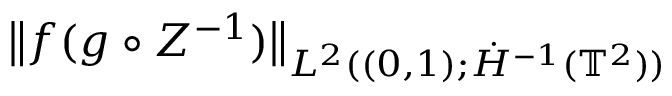Convert formula to latex. <formula><loc_0><loc_0><loc_500><loc_500>\begin{array} { r l } { { \left \| f ( g \circ Z ^ { - 1 } ) \right \| _ { L ^ { 2 } ( ( 0 , 1 ) ; \dot { H } ^ { - 1 } ( { \mathbb { T } } ^ { 2 } ) ) } } \quad } \end{array}</formula> 